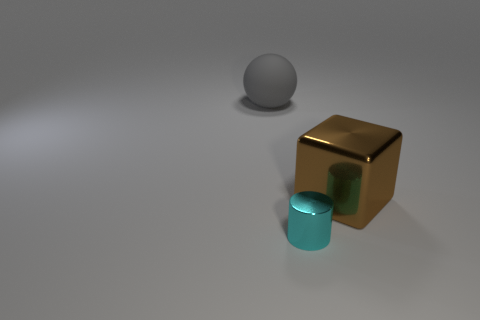What number of big objects are both left of the tiny cyan shiny object and to the right of the matte sphere?
Provide a short and direct response. 0. What number of matte objects are cyan cylinders or big blue blocks?
Ensure brevity in your answer.  0. There is a object that is in front of the large object in front of the large object behind the large brown cube; what is its material?
Keep it short and to the point. Metal. The large thing that is behind the metal thing that is behind the small cyan metal cylinder is made of what material?
Ensure brevity in your answer.  Rubber. Does the shiny object that is left of the large block have the same size as the thing that is behind the large brown thing?
Your answer should be compact. No. Are there any other things that have the same material as the sphere?
Offer a very short reply. No. What number of small objects are spheres or purple metal things?
Give a very brief answer. 0. What number of things are either big things that are right of the large gray matte object or small shiny cylinders?
Provide a succinct answer. 2. What number of other things are the same shape as the gray thing?
Your response must be concise. 0. What number of green things are either big blocks or matte things?
Provide a short and direct response. 0. 